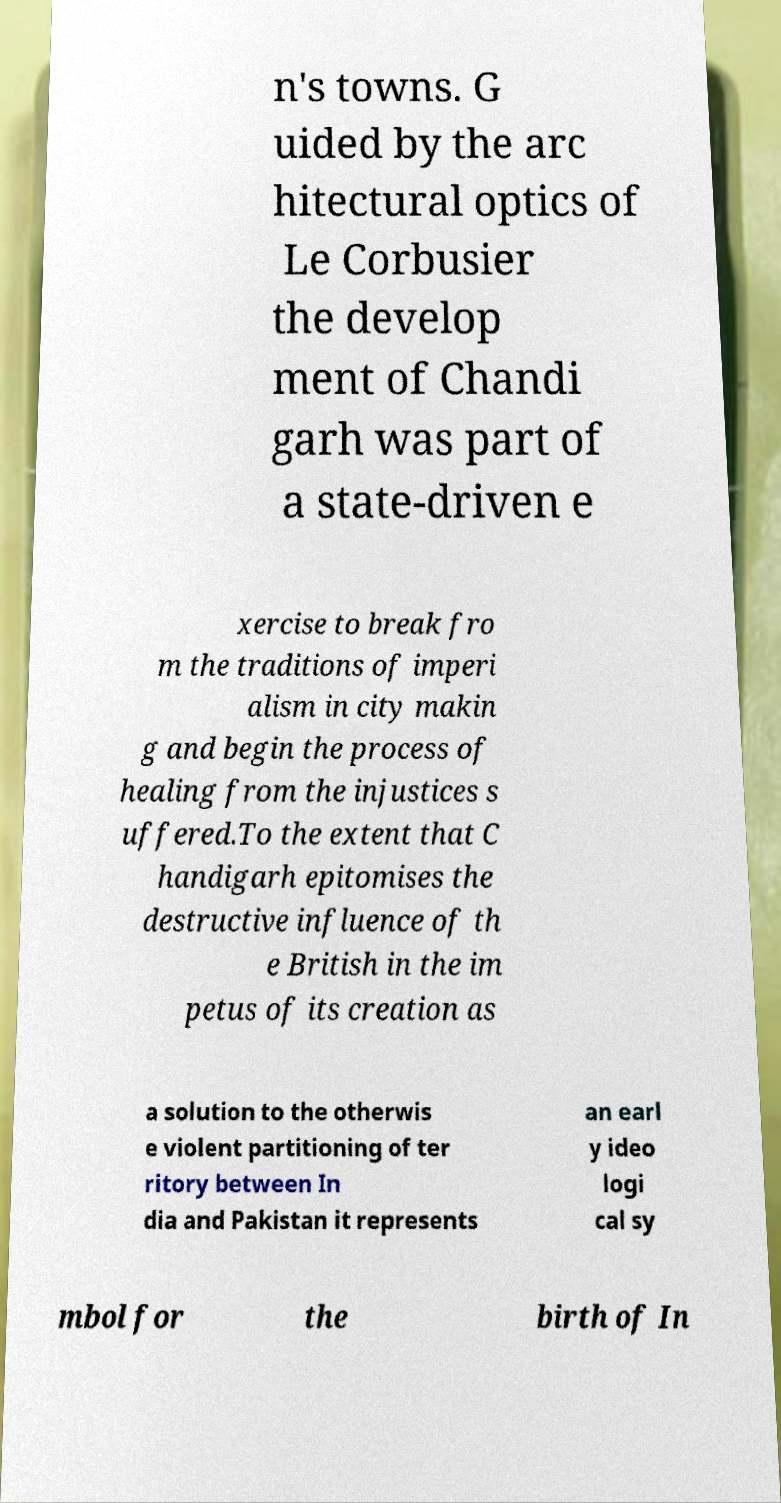Please read and relay the text visible in this image. What does it say? n's towns. G uided by the arc hitectural optics of Le Corbusier the develop ment of Chandi garh was part of a state-driven e xercise to break fro m the traditions of imperi alism in city makin g and begin the process of healing from the injustices s uffered.To the extent that C handigarh epitomises the destructive influence of th e British in the im petus of its creation as a solution to the otherwis e violent partitioning of ter ritory between In dia and Pakistan it represents an earl y ideo logi cal sy mbol for the birth of In 